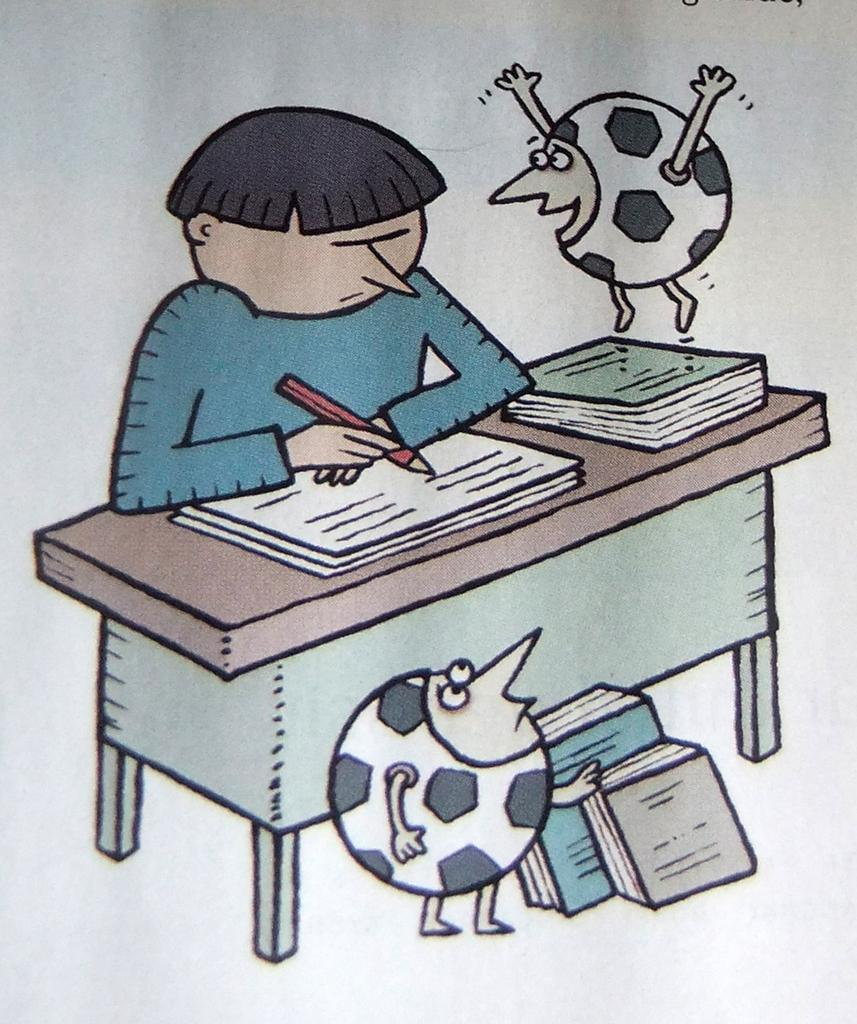What is the person in the image doing? The person is holding a pencil and writing on a paper. Where is the paper located? The paper is on a table. What else can be seen on the table? There are books on the table. What is happening with the ball in the image? There is a ball in the air and another ball on the floor. Are there any books beside the table? Yes, there are books beside the table. What type of mitten is the person wearing in the image? There is no mitten present in the image; the person is holding a pencil and writing on a paper. What sound does the crack make in the image? There is no crack present in the image. 